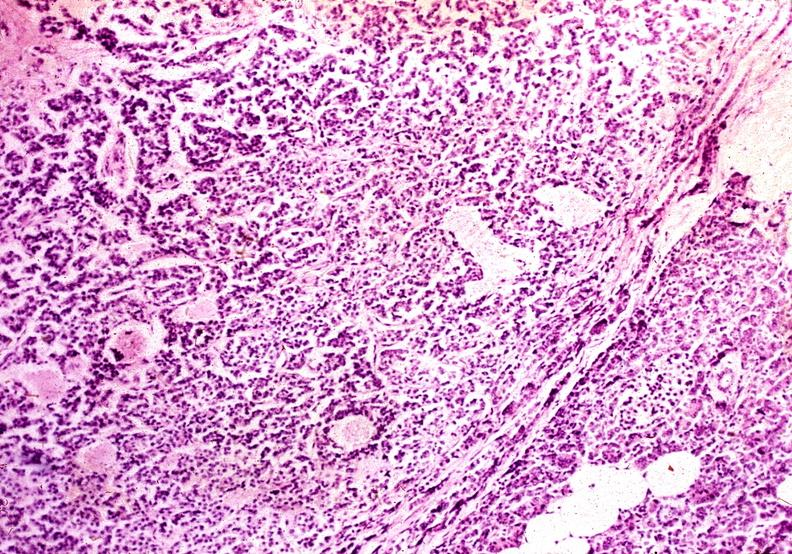does this image show islet cell carcinoma?
Answer the question using a single word or phrase. Yes 